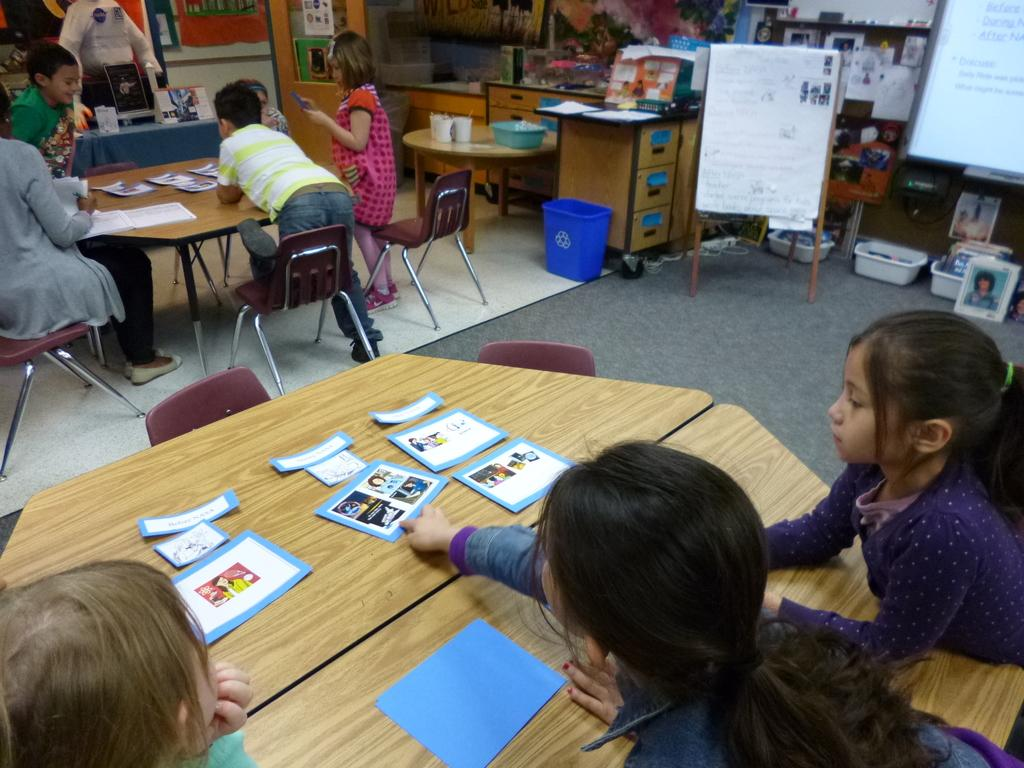What can be seen hanging on the walls in the image? There are posters in the image. Who or what is present in the image? There are people in the image. What type of furniture is visible in the image? There are chairs and tables in the image. What is placed on one of the tables in the image? There are cards on a table in the image. What type of vegetable is being served at the party in the image? There is no party or vegetable present in the image. How does the motion of the people in the image change throughout the scene? The image is static, so there is no motion of the people or any changes in their movements. 